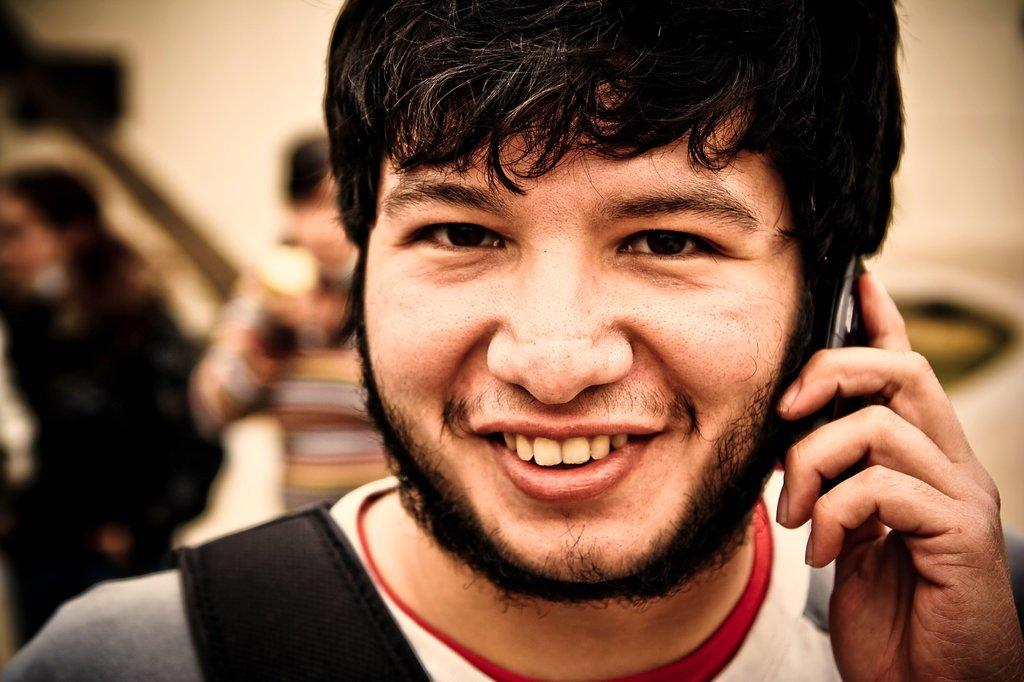Who is present in the image? There is a man in the image. What is the man doing in the image? The man is smiling in the image. What is the man holding in the image? The man is holding a mobile in the image. Can you describe the background of the image? The background of the image is blurry. What type of mint is growing in the background of the image? There is no mint present in the image; the background is blurry. How many friends are visible in the image? There are no friends visible in the image, only the man is present. 